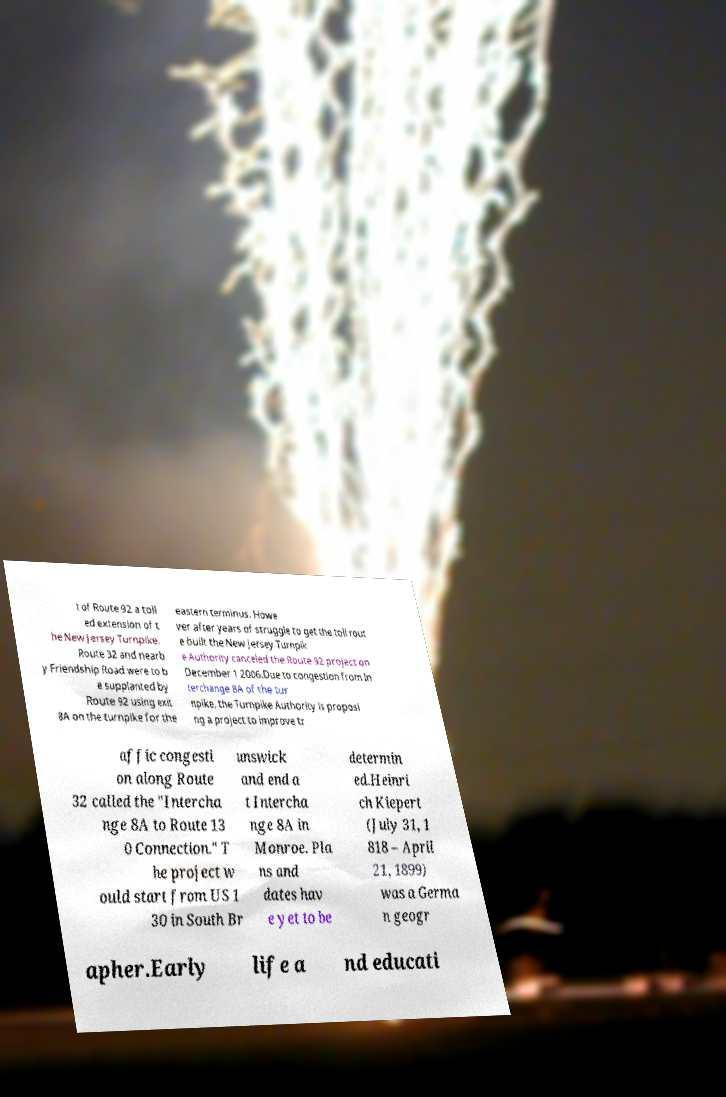Please read and relay the text visible in this image. What does it say? t of Route 92 a toll ed extension of t he New Jersey Turnpike. Route 32 and nearb y Friendship Road were to b e supplanted by Route 92 using exit 8A on the turnpike for the eastern terminus. Howe ver after years of struggle to get the toll rout e built the New Jersey Turnpik e Authority canceled the Route 92 project on December 1 2006.Due to congestion from In terchange 8A of the tur npike, the Turnpike Authority is proposi ng a project to improve tr affic congesti on along Route 32 called the "Intercha nge 8A to Route 13 0 Connection." T he project w ould start from US 1 30 in South Br unswick and end a t Intercha nge 8A in Monroe. Pla ns and dates hav e yet to be determin ed.Heinri ch Kiepert (July 31, 1 818 – April 21, 1899) was a Germa n geogr apher.Early life a nd educati 